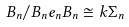<formula> <loc_0><loc_0><loc_500><loc_500>B _ { n } / B _ { n } e _ { n } B _ { n } \cong k \Sigma _ { n }</formula> 